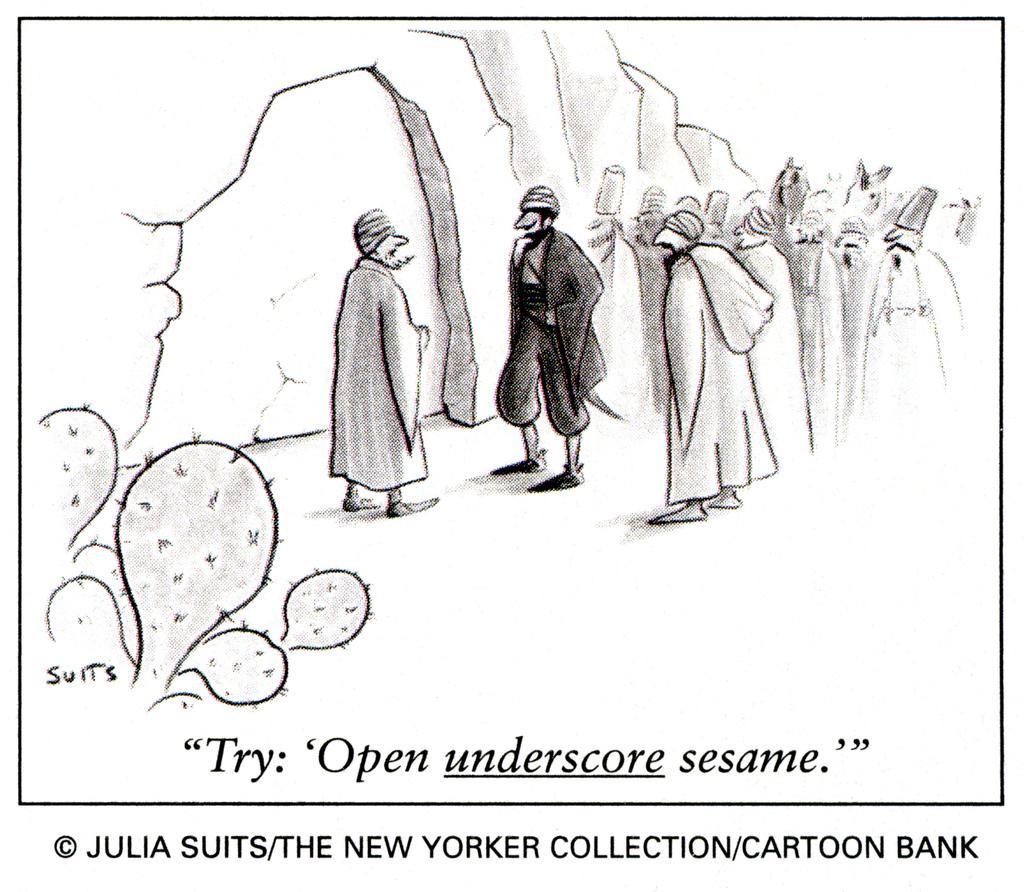In one or two sentences, can you explain what this image depicts? In this picture we can see people, plants, some text, a watermark and a few things. 